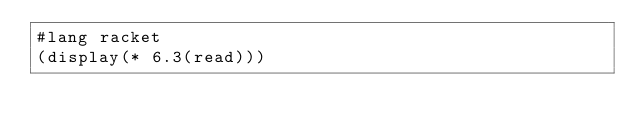Convert code to text. <code><loc_0><loc_0><loc_500><loc_500><_Racket_>#lang racket
(display(* 6.3(read)))</code> 